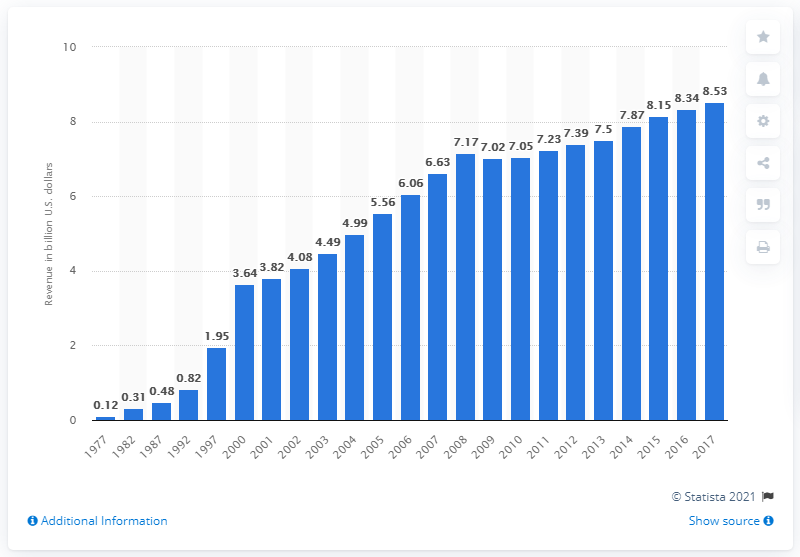Specify some key components in this picture. In 2017, state and local governments collected approximately $8.53 billion in amusement tax revenue. 